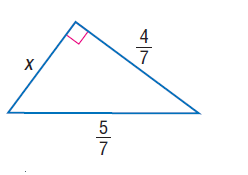Answer the mathemtical geometry problem and directly provide the correct option letter.
Question: Find x.
Choices: A: \frac { 1 } { 7 } B: \frac { 3 } { 7 } C: \frac { 4 } { 7 } D: \frac { 5 } { 7 } B 